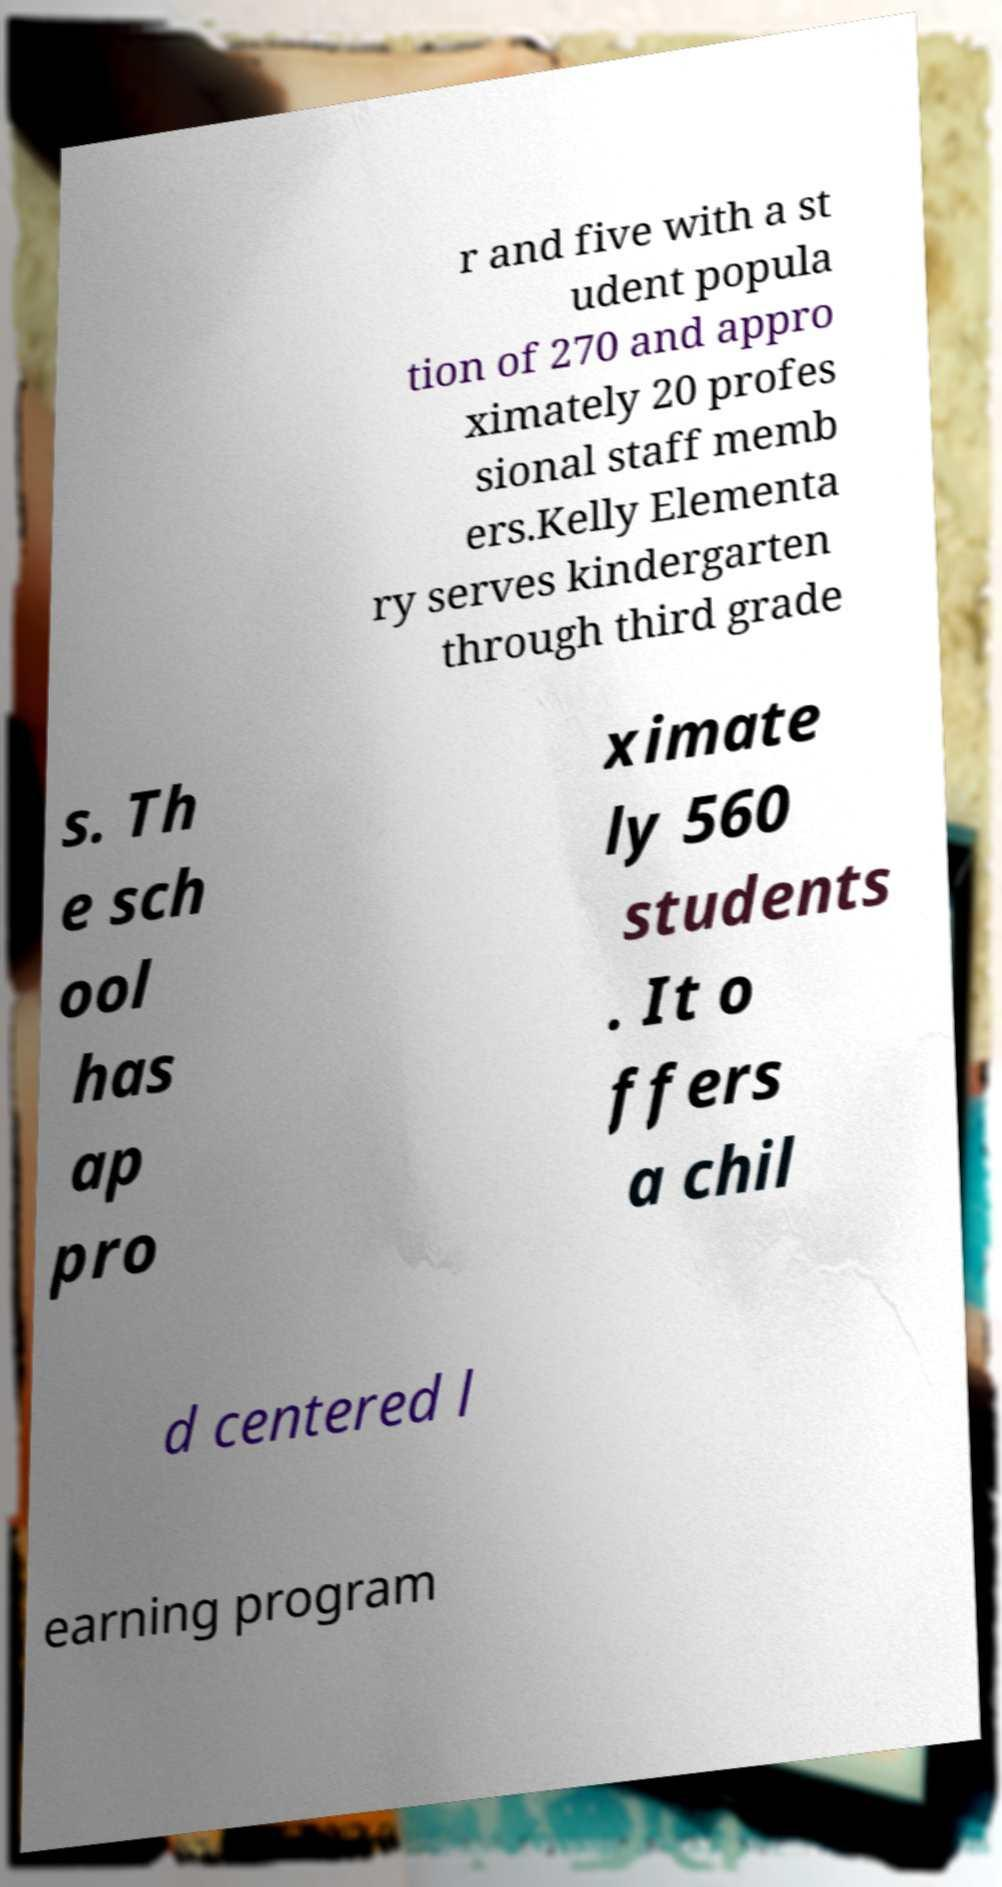Can you read and provide the text displayed in the image?This photo seems to have some interesting text. Can you extract and type it out for me? r and five with a st udent popula tion of 270 and appro ximately 20 profes sional staff memb ers.Kelly Elementa ry serves kindergarten through third grade s. Th e sch ool has ap pro ximate ly 560 students . It o ffers a chil d centered l earning program 